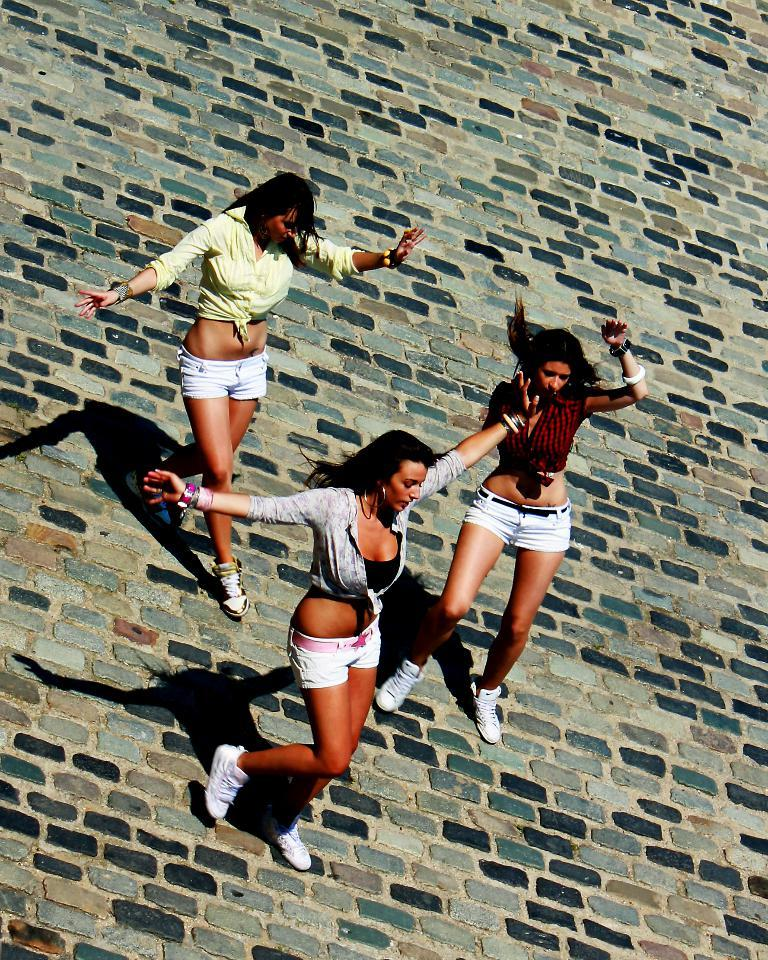How many people are in the image? There are three women in the image. Where are the women located in the image? The women are standing in the middle of the image. What are the women doing in the image? The women are doing something, but the specific activity cannot be determined from the provided facts. What type of slip is the woman on the left wearing in the image? There is no information about clothing or accessories in the image, so it cannot be determined if any of the women are wearing a slip. 